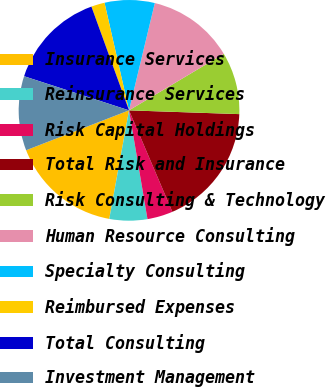Convert chart to OTSL. <chart><loc_0><loc_0><loc_500><loc_500><pie_chart><fcel>Insurance Services<fcel>Reinsurance Services<fcel>Risk Capital Holdings<fcel>Total Risk and Insurance<fcel>Risk Consulting & Technology<fcel>Human Resource Consulting<fcel>Specialty Consulting<fcel>Reimbursed Expenses<fcel>Total Consulting<fcel>Investment Management<nl><fcel>16.25%<fcel>5.54%<fcel>3.75%<fcel>18.03%<fcel>9.11%<fcel>12.68%<fcel>7.32%<fcel>1.97%<fcel>14.46%<fcel>10.89%<nl></chart> 